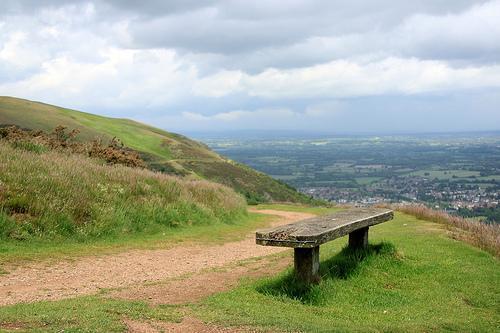How many benches are in the photo?
Give a very brief answer. 1. 